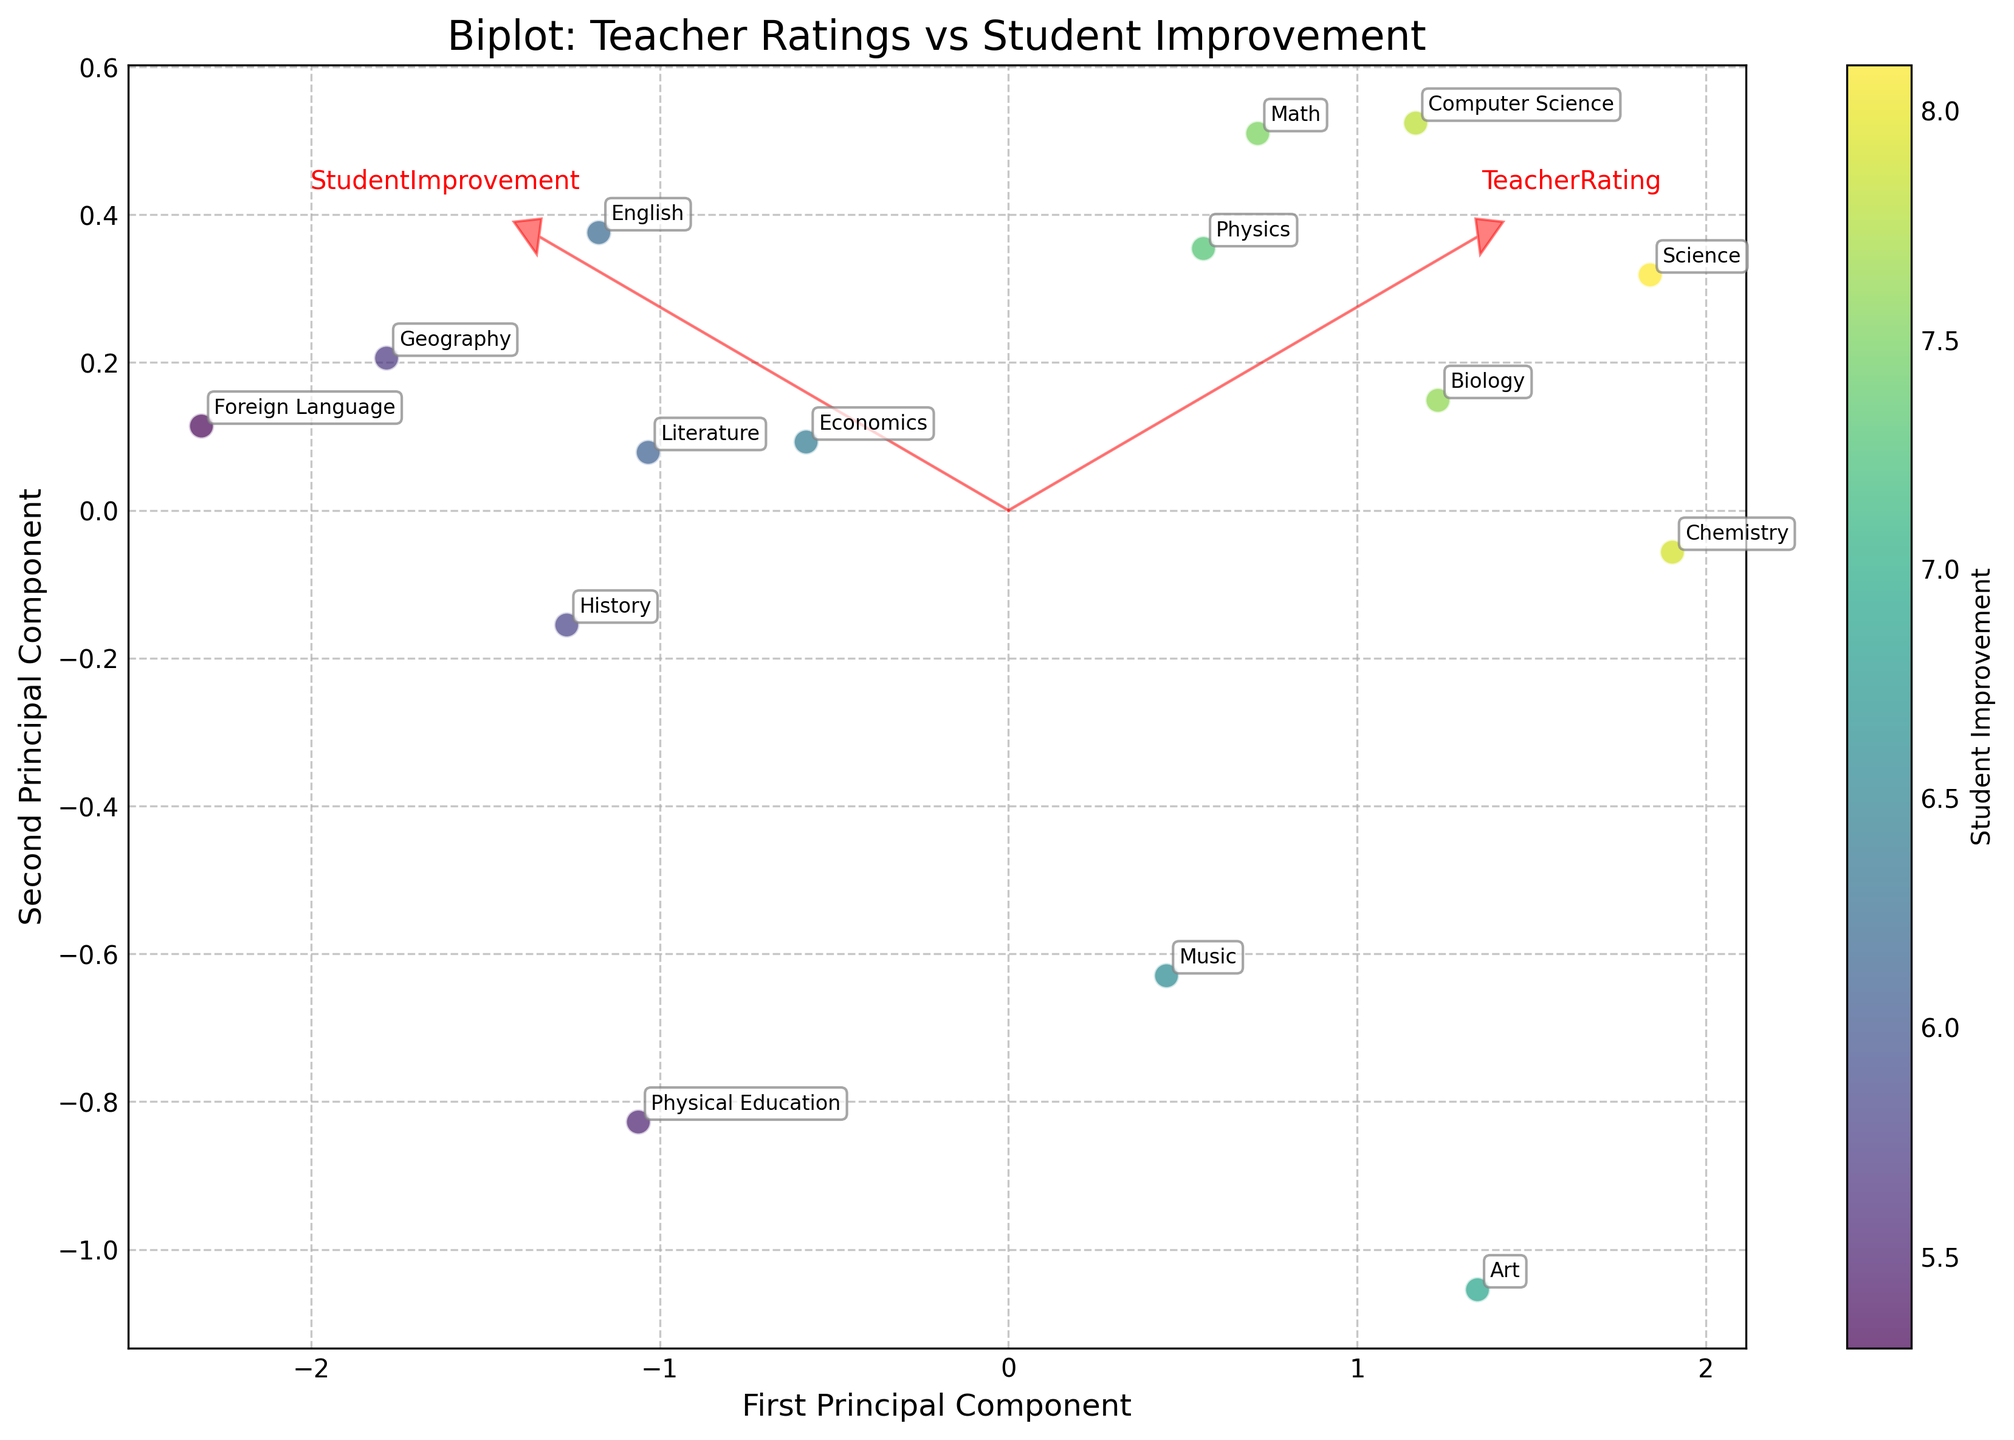What's the title of the plot? The title of the plot is usually placed at the top center of the figure. In this case, according to the provided code, the title is "Biplot: Teacher Ratings vs Student Improvement"
Answer: Biplot: Teacher Ratings vs Student Improvement How many data points are plotted in the biplot? To find the number of data points, we can count the individual markers on the plot. The number of points corresponds to the number of subjects in the data set, which is listed in the provided data. There are 15 subjects listed.
Answer: 15 Which subject shows the highest student improvement? By inspecting the plot and looking at the labels closest to the highest values on the second principal component axis (which is associated with higher student improvement), we identify that Science has the highest student improvement according to the provided data.
Answer: Science What does the color of the data points represent? The color of the data points is explained in the code as being mapped to "Student Improvement" using the 'viridis' colormap. This means different shades represent varying levels of student improvement.
Answer: Student Improvement Which subjects have the lowest teacher ratings and where are they positioned in the biplot? To determine this, we look for points labeled with subjects that are near the lower end of the first principal component axis, as this axis relates to "Teacher Ratings." According to the data, "Foreign Language" has the lowest teacher rating.
Answer: Foreign Language, positioned towards the left of the first principal component axis What direction do the teacher rating vector arrows point towards? The arrows for the teacher rating vector in the biplot are projected along the direction which maximizes variance explained for teacher ratings. By examining the plot, we can see that these arrows point predominantly towards the right side of the plot.
Answer: Right Which subject is closer to the eigenvector associated with the highest student improvement? In terms of PCA, we find the eigenvector for student improvement based on the arrows and look at which subject point is closely aligned with this vector. For the highest student improvement, "Science" appears closest.
Answer: Science Compare Math and English regarding their teacher ratings and student improvements. Comparing the positions, Math has a higher teacher rating and student improvement compared to English. Math's point is situated towards the right and upward in the plot compared to English's point which is left and downward.
Answer: Math has higher teacher rating and student improvement than English Consider the subject of Art and Music. Which one has a higher student improvement, and how do you determine that from the plot? We look at the positions of Art and Music on the second principal component axis. The further a point is along this axis, the higher the student improvement. Art is displayed higher on the second component axis than Music.
Answer: Art Identify the subject closest to the origin of the biplot and explain what this suggests about its teacher ratings and student improvement. The subject closest to the origin will have average values for both teacher ratings and student improvement, as the origin represents the mean-centered points in PCA. Looking at the plot, Physical Education appears closest to the origin.
Answer: Physical Education 